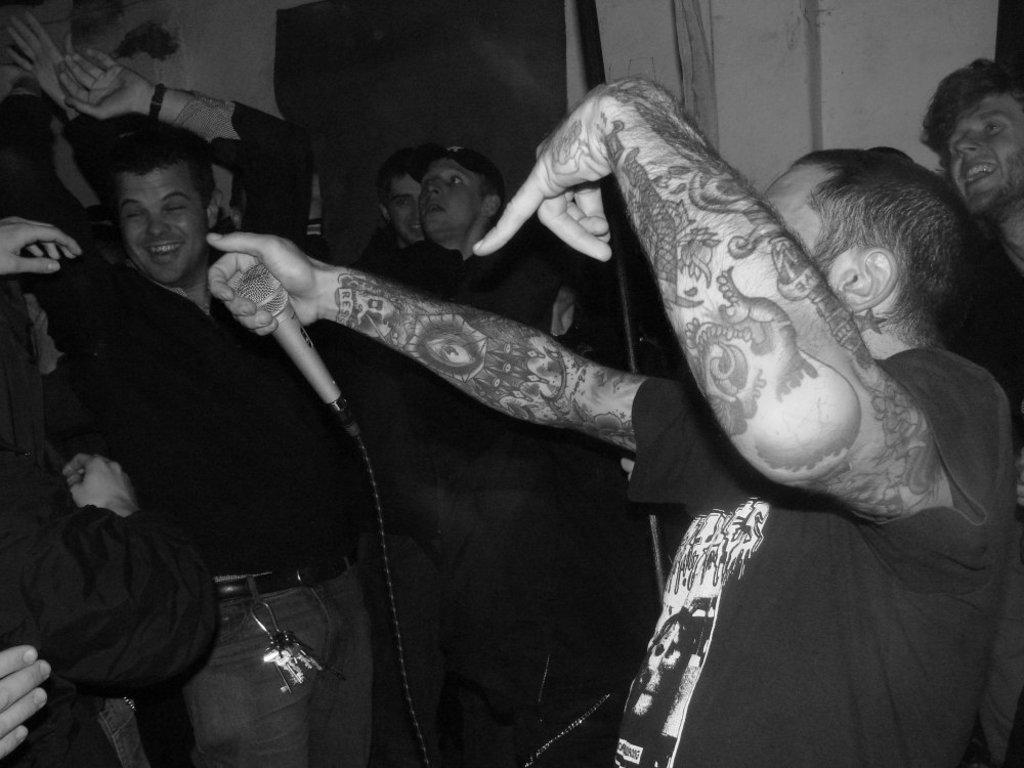What are the people in the image doing? The people in the image are dancing. What expression do the people have on their faces? The people have smiles on their faces. What object is one person holding in their hand? One person is holding a microphone in their hand. What can be seen in the background of the image? There is a wall in the background of the image. Can you tell me how many robins are perched on the wall in the image? There are no robins present in the image; it features people dancing with a wall in the background. What type of legal advice is the person with the microphone providing in the image? There is no indication in the image that the person with the microphone is providing legal advice, as they are holding a microphone while dancing. 